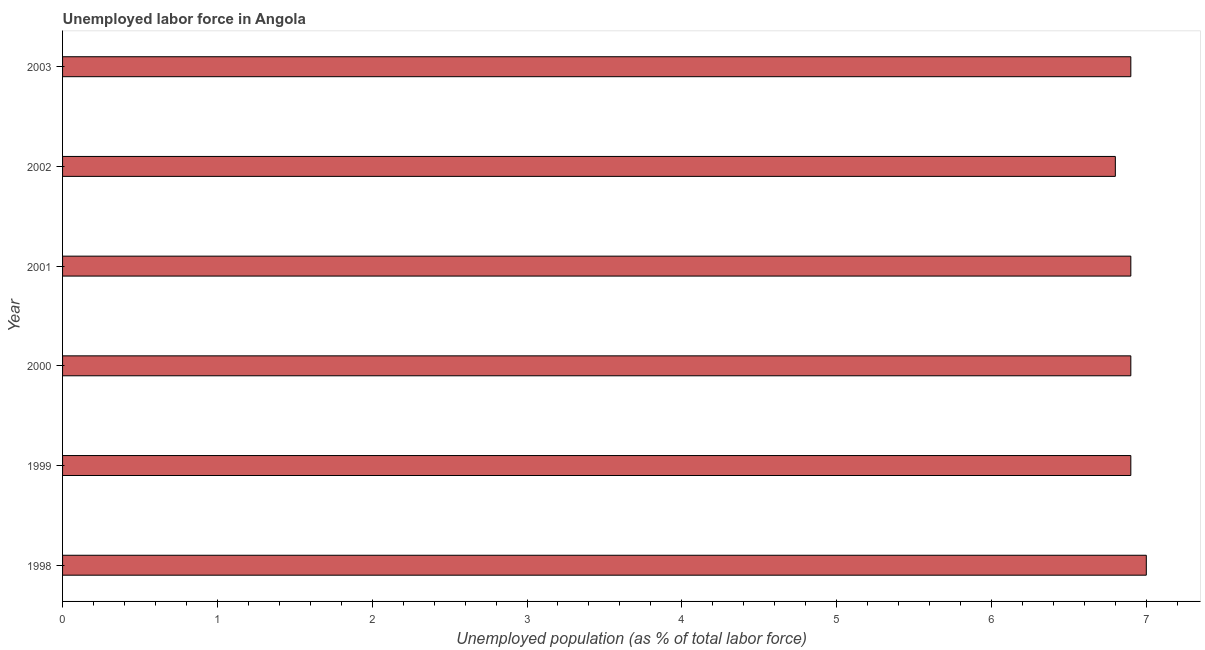Does the graph contain grids?
Provide a short and direct response. No. What is the title of the graph?
Ensure brevity in your answer.  Unemployed labor force in Angola. What is the label or title of the X-axis?
Your answer should be very brief. Unemployed population (as % of total labor force). What is the total unemployed population in 2000?
Your answer should be very brief. 6.9. Across all years, what is the minimum total unemployed population?
Your response must be concise. 6.8. In which year was the total unemployed population maximum?
Your answer should be very brief. 1998. In which year was the total unemployed population minimum?
Provide a short and direct response. 2002. What is the sum of the total unemployed population?
Offer a very short reply. 41.4. What is the difference between the total unemployed population in 1999 and 2001?
Your answer should be very brief. 0. What is the median total unemployed population?
Your response must be concise. 6.9. Is the total unemployed population in 1999 less than that in 2003?
Your answer should be very brief. No. In how many years, is the total unemployed population greater than the average total unemployed population taken over all years?
Your answer should be compact. 1. How many bars are there?
Your answer should be very brief. 6. Are all the bars in the graph horizontal?
Provide a short and direct response. Yes. How many years are there in the graph?
Your response must be concise. 6. What is the difference between two consecutive major ticks on the X-axis?
Your answer should be very brief. 1. What is the Unemployed population (as % of total labor force) in 1999?
Your answer should be compact. 6.9. What is the Unemployed population (as % of total labor force) in 2000?
Ensure brevity in your answer.  6.9. What is the Unemployed population (as % of total labor force) in 2001?
Your answer should be compact. 6.9. What is the Unemployed population (as % of total labor force) in 2002?
Make the answer very short. 6.8. What is the Unemployed population (as % of total labor force) of 2003?
Your answer should be very brief. 6.9. What is the difference between the Unemployed population (as % of total labor force) in 1998 and 1999?
Provide a succinct answer. 0.1. What is the difference between the Unemployed population (as % of total labor force) in 1998 and 2000?
Keep it short and to the point. 0.1. What is the difference between the Unemployed population (as % of total labor force) in 1998 and 2002?
Provide a short and direct response. 0.2. What is the difference between the Unemployed population (as % of total labor force) in 1999 and 2001?
Provide a succinct answer. 0. What is the difference between the Unemployed population (as % of total labor force) in 1999 and 2003?
Give a very brief answer. 0. What is the difference between the Unemployed population (as % of total labor force) in 2000 and 2002?
Give a very brief answer. 0.1. What is the difference between the Unemployed population (as % of total labor force) in 2001 and 2002?
Provide a short and direct response. 0.1. What is the difference between the Unemployed population (as % of total labor force) in 2001 and 2003?
Your answer should be very brief. 0. What is the difference between the Unemployed population (as % of total labor force) in 2002 and 2003?
Offer a terse response. -0.1. What is the ratio of the Unemployed population (as % of total labor force) in 1998 to that in 1999?
Keep it short and to the point. 1.01. What is the ratio of the Unemployed population (as % of total labor force) in 1998 to that in 2000?
Your answer should be compact. 1.01. What is the ratio of the Unemployed population (as % of total labor force) in 1998 to that in 2001?
Offer a very short reply. 1.01. What is the ratio of the Unemployed population (as % of total labor force) in 1998 to that in 2003?
Your answer should be compact. 1.01. What is the ratio of the Unemployed population (as % of total labor force) in 1999 to that in 2003?
Your answer should be very brief. 1. What is the ratio of the Unemployed population (as % of total labor force) in 2000 to that in 2001?
Your answer should be very brief. 1. What is the ratio of the Unemployed population (as % of total labor force) in 2000 to that in 2003?
Your response must be concise. 1. What is the ratio of the Unemployed population (as % of total labor force) in 2001 to that in 2002?
Give a very brief answer. 1.01. What is the ratio of the Unemployed population (as % of total labor force) in 2001 to that in 2003?
Make the answer very short. 1. What is the ratio of the Unemployed population (as % of total labor force) in 2002 to that in 2003?
Give a very brief answer. 0.99. 